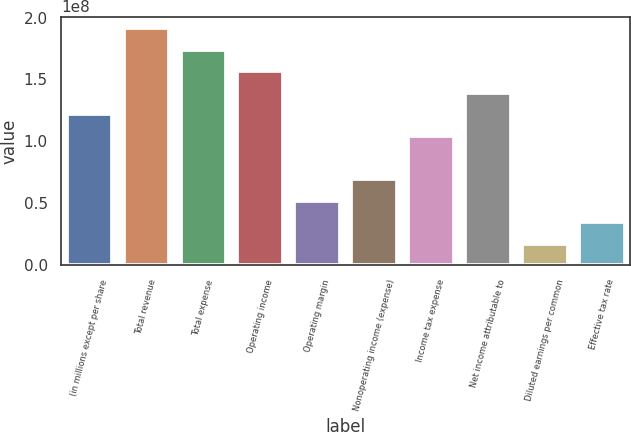<chart> <loc_0><loc_0><loc_500><loc_500><bar_chart><fcel>(in millions except per share<fcel>Total revenue<fcel>Total expense<fcel>Operating income<fcel>Operating margin<fcel>Nonoperating income (expense)<fcel>Income tax expense<fcel>Net income attributable to<fcel>Diluted earnings per common<fcel>Effective tax rate<nl><fcel>1.2168e+08<fcel>1.91212e+08<fcel>1.73829e+08<fcel>1.56446e+08<fcel>5.21487e+07<fcel>6.95316e+07<fcel>1.04297e+08<fcel>1.39063e+08<fcel>1.73829e+07<fcel>3.47658e+07<nl></chart> 